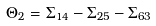<formula> <loc_0><loc_0><loc_500><loc_500>\Theta _ { 2 } = \Sigma _ { 1 4 } - \Sigma _ { 2 5 } - \Sigma _ { 6 3 }</formula> 